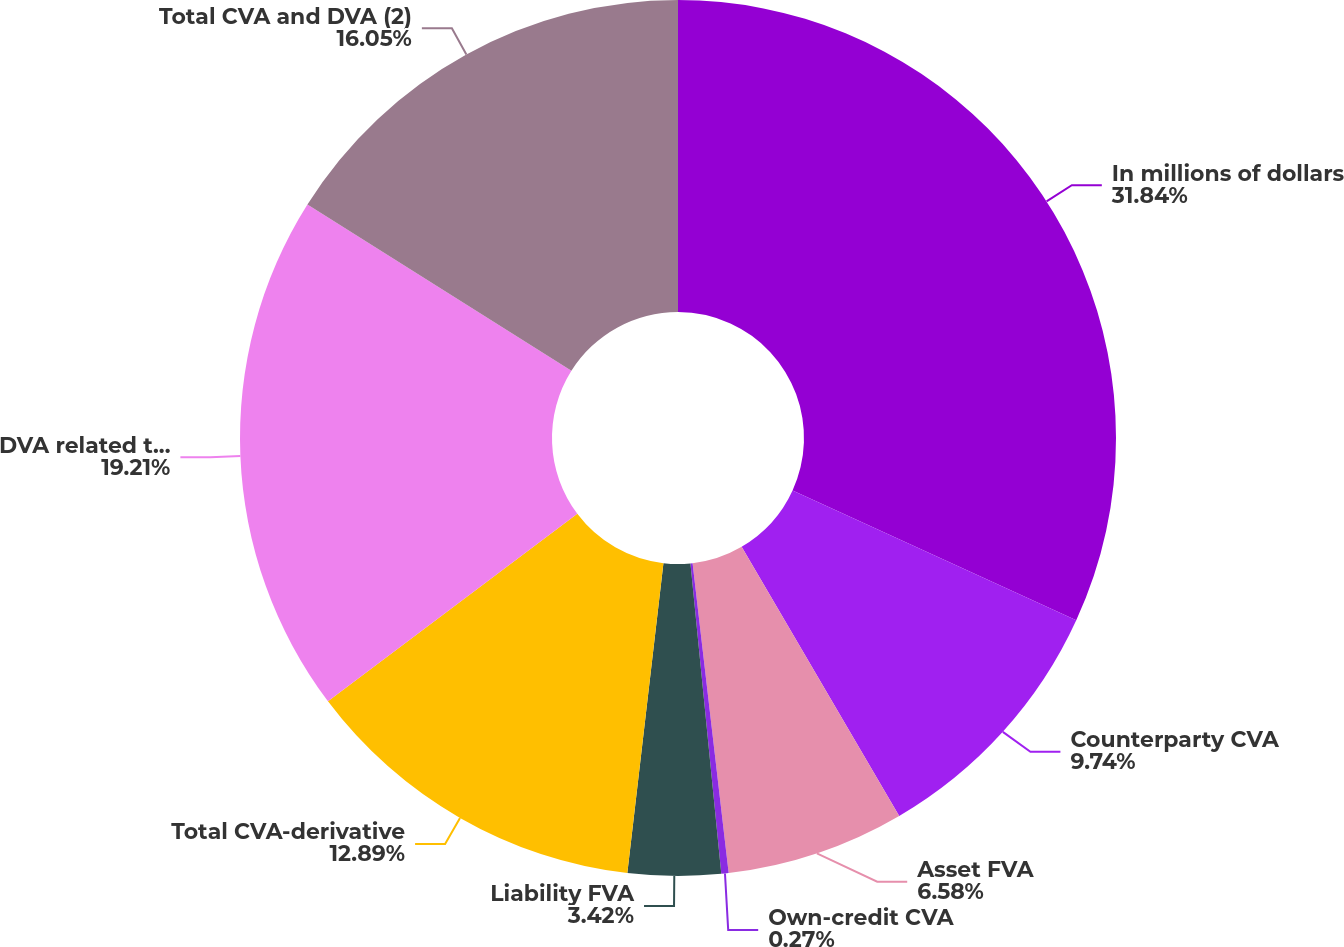Convert chart to OTSL. <chart><loc_0><loc_0><loc_500><loc_500><pie_chart><fcel>In millions of dollars<fcel>Counterparty CVA<fcel>Asset FVA<fcel>Own-credit CVA<fcel>Liability FVA<fcel>Total CVA-derivative<fcel>DVA related to own FVO<fcel>Total CVA and DVA (2)<nl><fcel>31.83%<fcel>9.74%<fcel>6.58%<fcel>0.27%<fcel>3.42%<fcel>12.89%<fcel>19.21%<fcel>16.05%<nl></chart> 